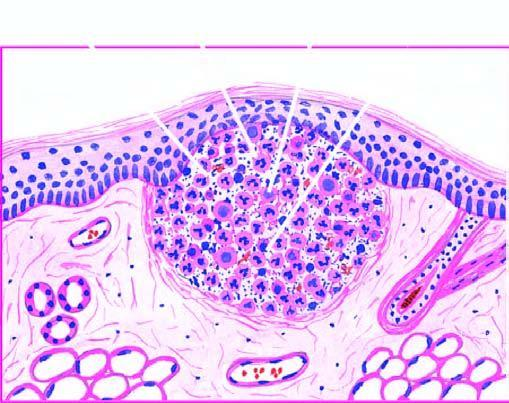where are some macrophages seen?
Answer the question using a single word or phrase. At the periphery 